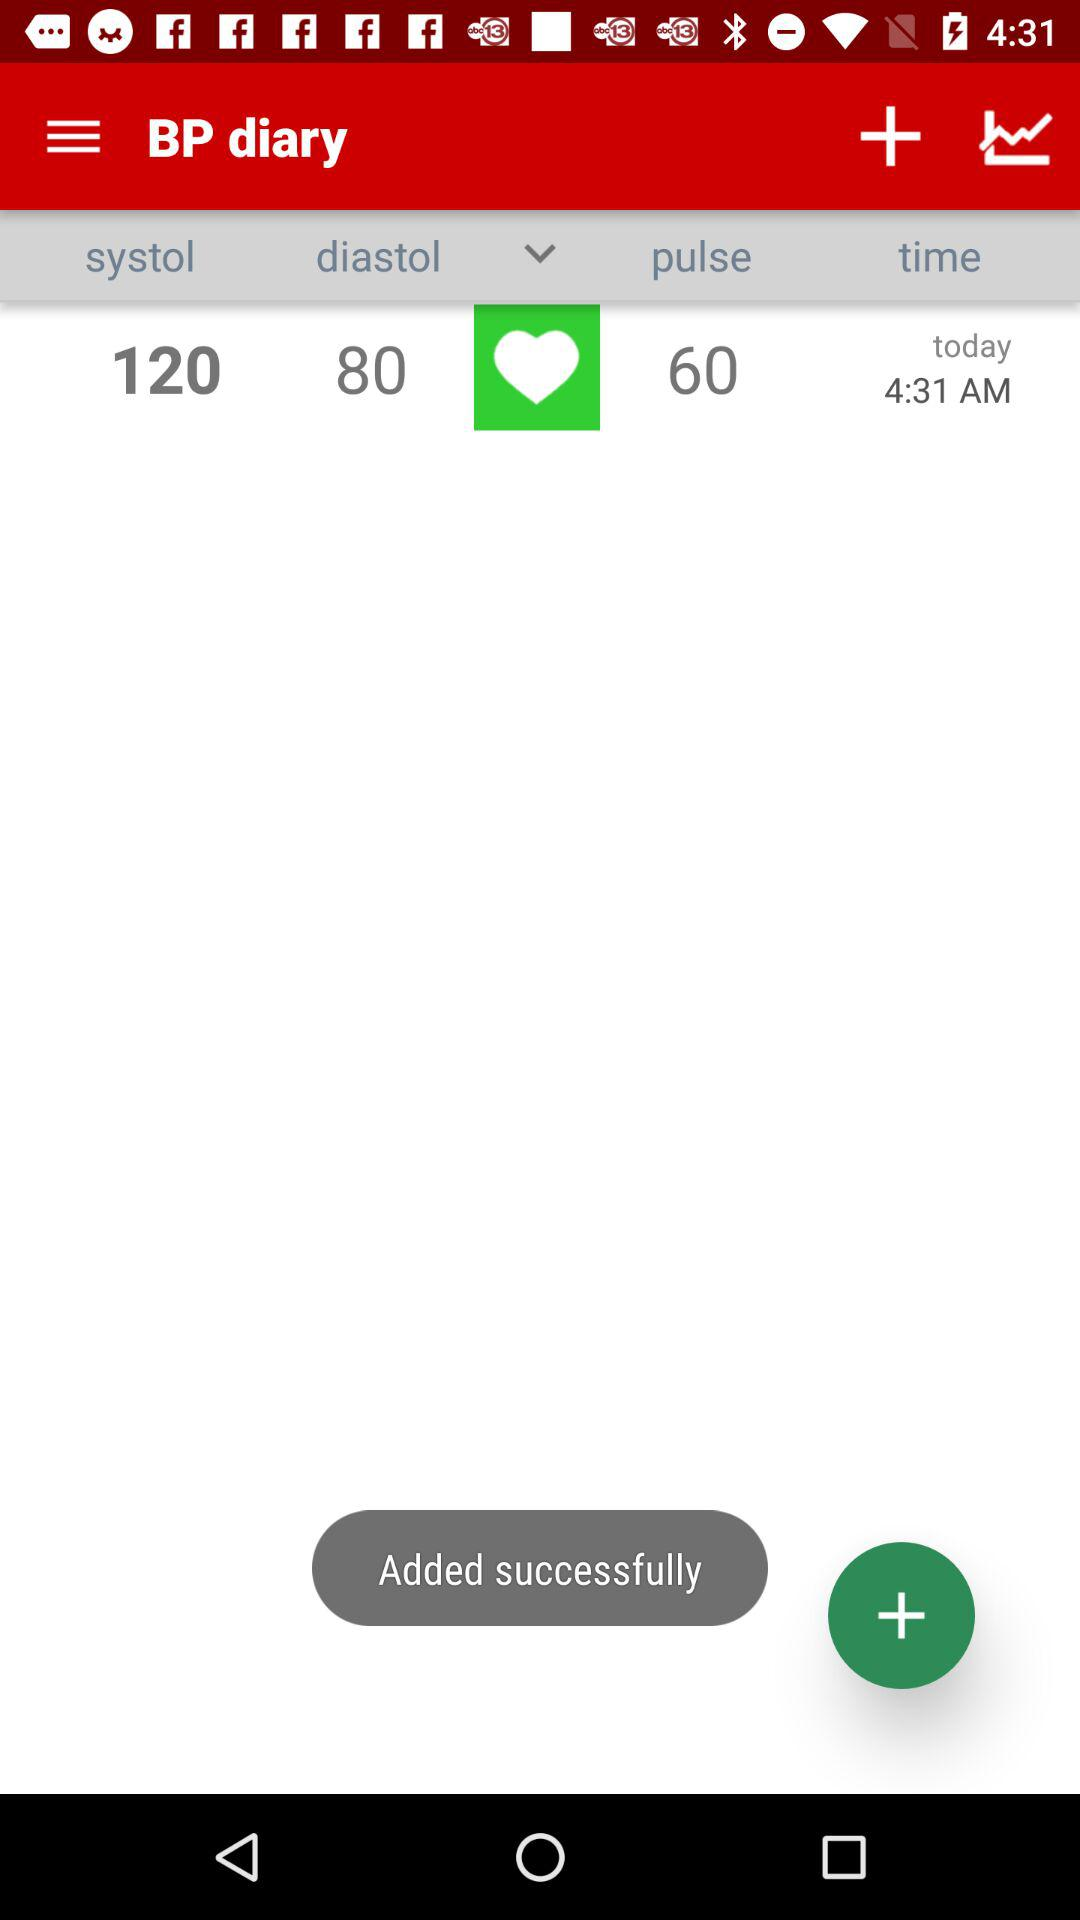What is the difference between the systolic and diastolic blood pressure values?
Answer the question using a single word or phrase. 40 